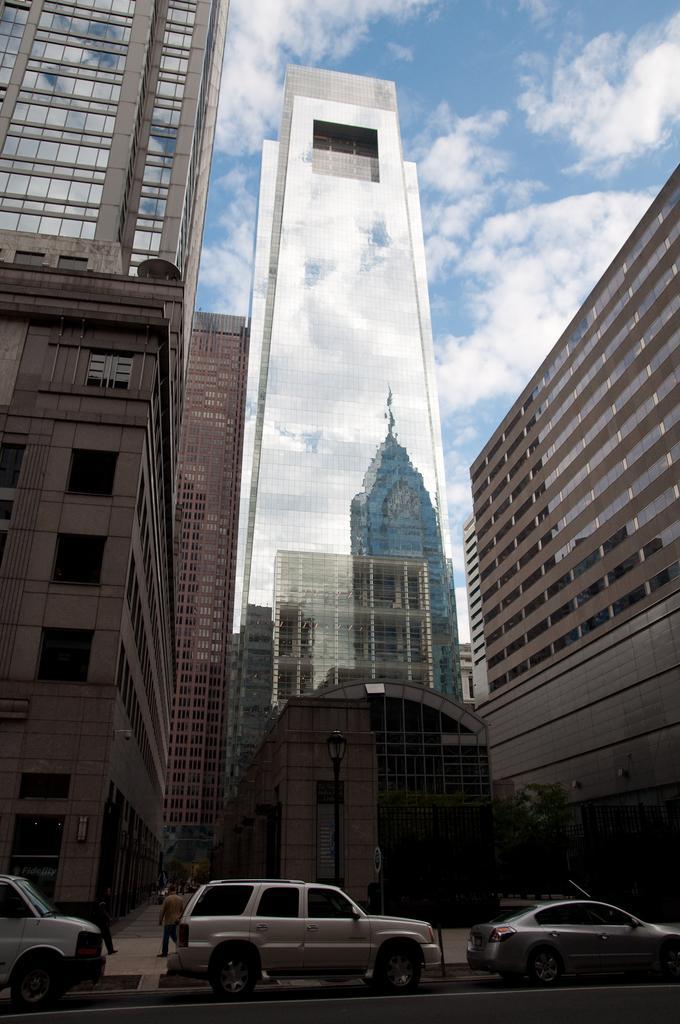Can you describe this image briefly? In this image on the road there are few cars. In the background there are buildings. Here there are persons. The sky is cloudy. 